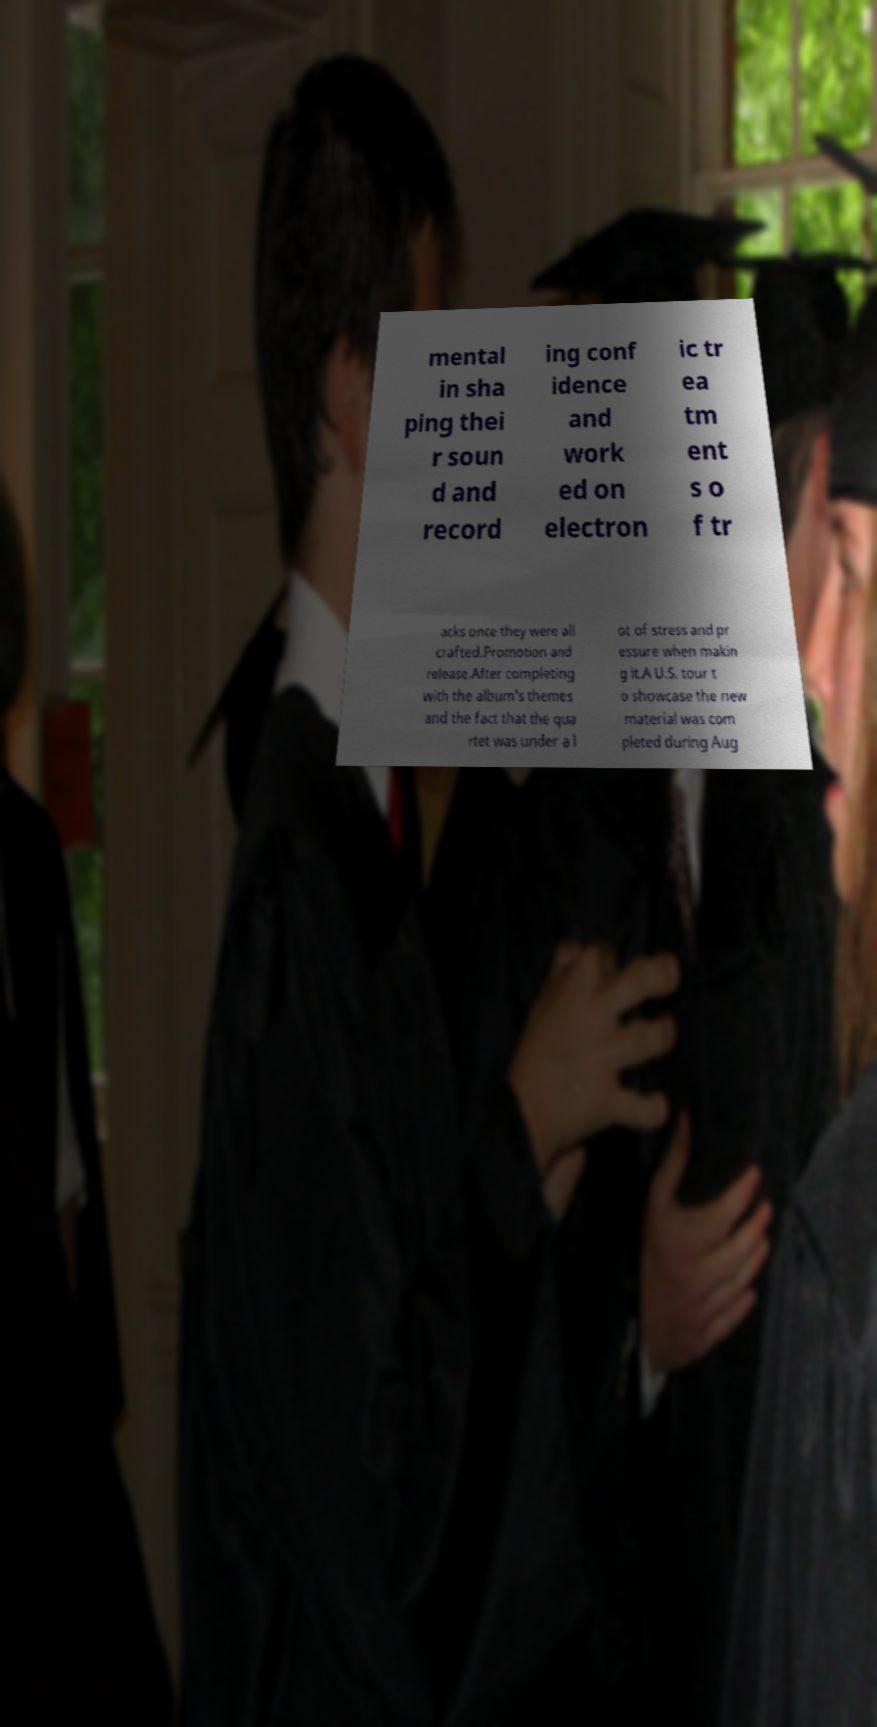There's text embedded in this image that I need extracted. Can you transcribe it verbatim? mental in sha ping thei r soun d and record ing conf idence and work ed on electron ic tr ea tm ent s o f tr acks once they were all crafted.Promotion and release.After completing with the album's themes and the fact that the qua rtet was under a l ot of stress and pr essure when makin g it.A U.S. tour t o showcase the new material was com pleted during Aug 